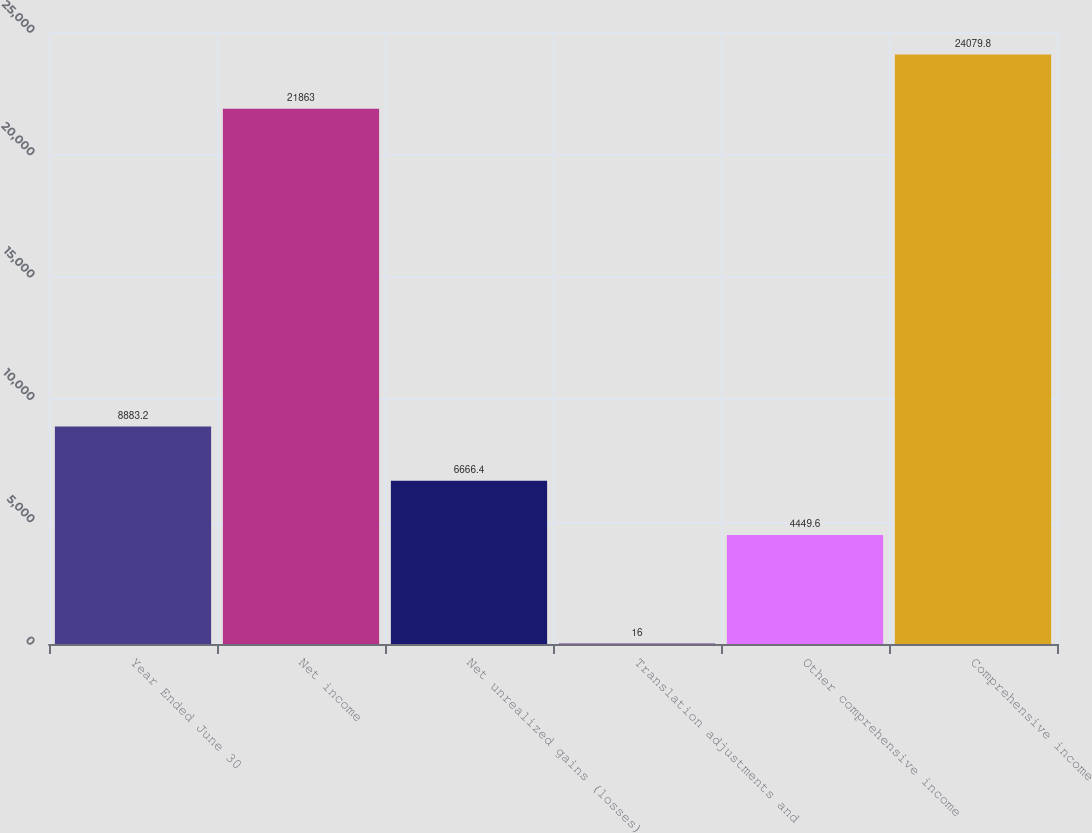<chart> <loc_0><loc_0><loc_500><loc_500><bar_chart><fcel>Year Ended June 30<fcel>Net income<fcel>Net unrealized gains (losses)<fcel>Translation adjustments and<fcel>Other comprehensive income<fcel>Comprehensive income<nl><fcel>8883.2<fcel>21863<fcel>6666.4<fcel>16<fcel>4449.6<fcel>24079.8<nl></chart> 